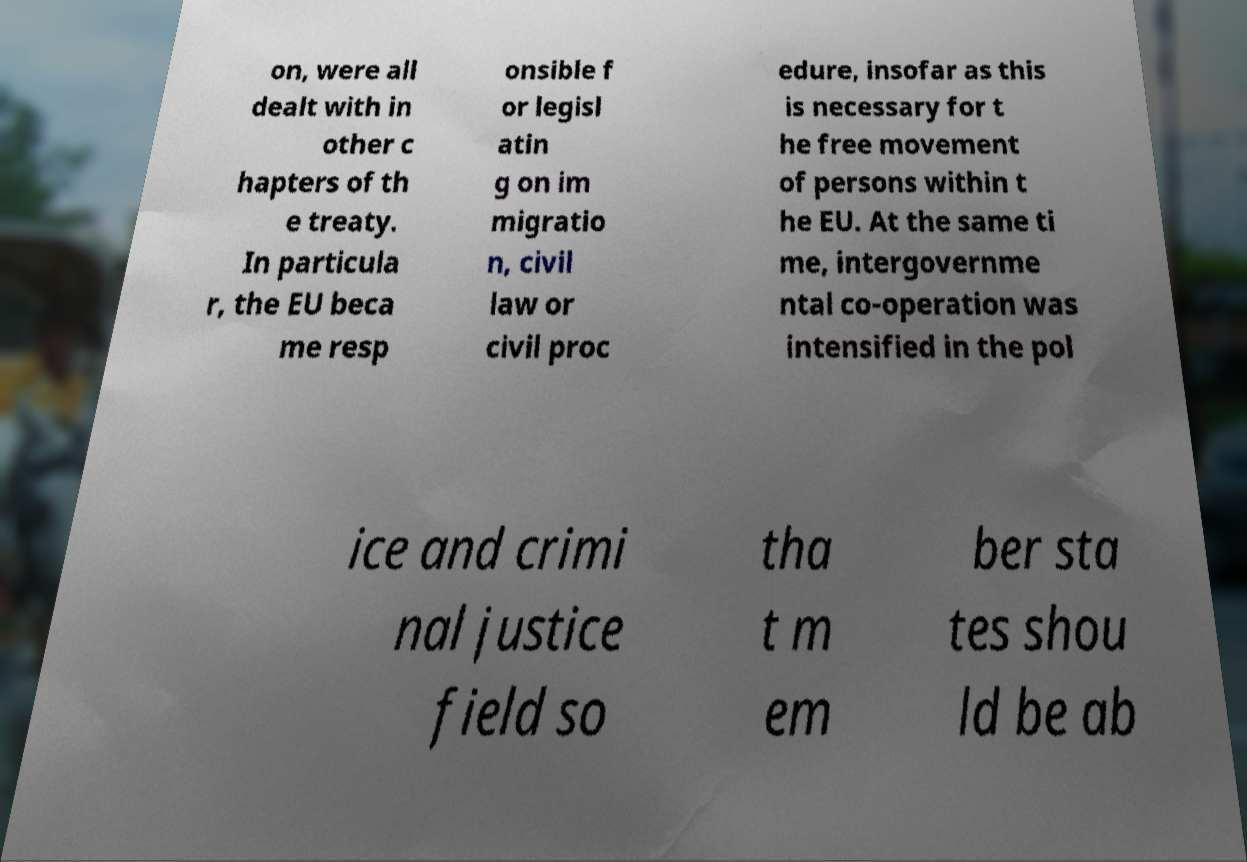Could you extract and type out the text from this image? on, were all dealt with in other c hapters of th e treaty. In particula r, the EU beca me resp onsible f or legisl atin g on im migratio n, civil law or civil proc edure, insofar as this is necessary for t he free movement of persons within t he EU. At the same ti me, intergovernme ntal co-operation was intensified in the pol ice and crimi nal justice field so tha t m em ber sta tes shou ld be ab 